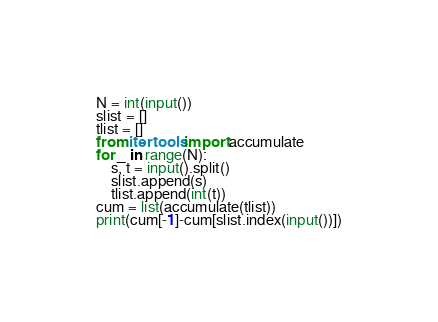Convert code to text. <code><loc_0><loc_0><loc_500><loc_500><_Python_>N = int(input())
slist = []
tlist = []
from itertools import accumulate
for _ in range(N):
    s, t = input().split()
    slist.append(s)
    tlist.append(int(t))
cum = list(accumulate(tlist))
print(cum[-1]-cum[slist.index(input())])
</code> 